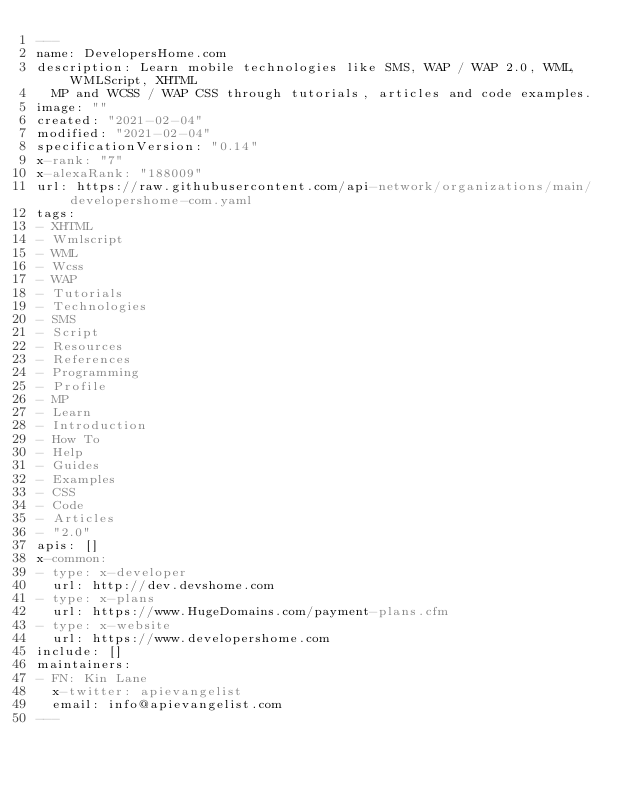Convert code to text. <code><loc_0><loc_0><loc_500><loc_500><_YAML_>---
name: DevelopersHome.com
description: Learn mobile technologies like SMS, WAP / WAP 2.0, WML, WMLScript, XHTML
  MP and WCSS / WAP CSS through tutorials, articles and code examples.
image: ""
created: "2021-02-04"
modified: "2021-02-04"
specificationVersion: "0.14"
x-rank: "7"
x-alexaRank: "188009"
url: https://raw.githubusercontent.com/api-network/organizations/main/developershome-com.yaml
tags:
- XHTML
- Wmlscript
- WML
- Wcss
- WAP
- Tutorials
- Technologies
- SMS
- Script
- Resources
- References
- Programming
- Profile
- MP
- Learn
- Introduction
- How To
- Help
- Guides
- Examples
- CSS
- Code
- Articles
- "2.0"
apis: []
x-common:
- type: x-developer
  url: http://dev.devshome.com
- type: x-plans
  url: https://www.HugeDomains.com/payment-plans.cfm
- type: x-website
  url: https://www.developershome.com
include: []
maintainers:
- FN: Kin Lane
  x-twitter: apievangelist
  email: info@apievangelist.com
---</code> 